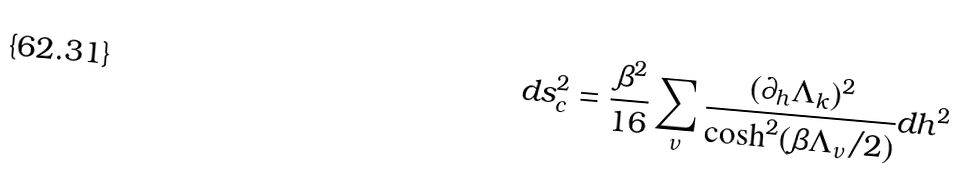<formula> <loc_0><loc_0><loc_500><loc_500>d s _ { c } ^ { 2 } = \frac { \beta ^ { 2 } } { 1 6 } \sum _ { \nu } \frac { ( \partial _ { h } \Lambda _ { k } ) ^ { 2 } } { \cosh ^ { 2 } ( \beta \Lambda _ { \nu } / 2 ) } d h ^ { 2 }</formula> 